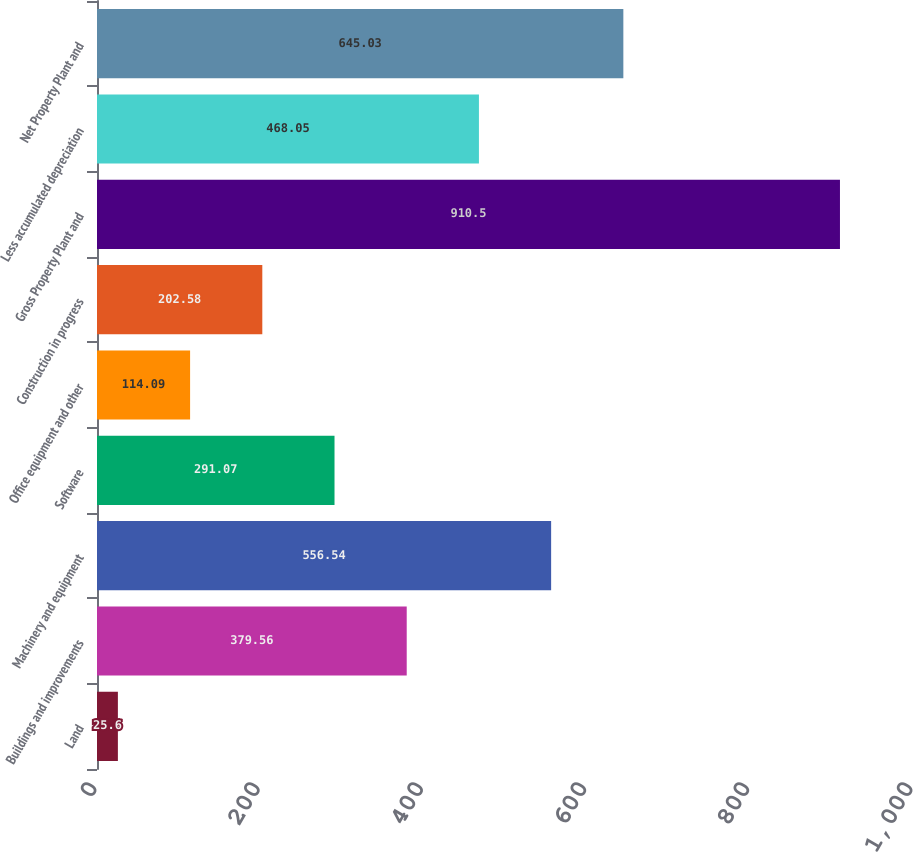<chart> <loc_0><loc_0><loc_500><loc_500><bar_chart><fcel>Land<fcel>Buildings and improvements<fcel>Machinery and equipment<fcel>Software<fcel>Office equipment and other<fcel>Construction in progress<fcel>Gross Property Plant and<fcel>Less accumulated depreciation<fcel>Net Property Plant and<nl><fcel>25.6<fcel>379.56<fcel>556.54<fcel>291.07<fcel>114.09<fcel>202.58<fcel>910.5<fcel>468.05<fcel>645.03<nl></chart> 